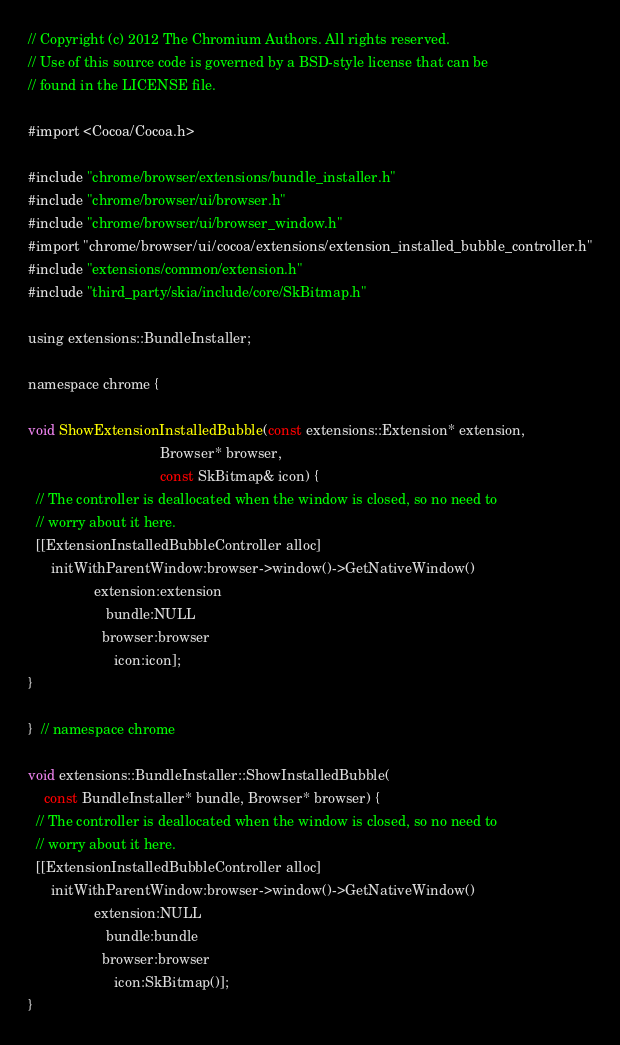Convert code to text. <code><loc_0><loc_0><loc_500><loc_500><_ObjectiveC_>// Copyright (c) 2012 The Chromium Authors. All rights reserved.
// Use of this source code is governed by a BSD-style license that can be
// found in the LICENSE file.

#import <Cocoa/Cocoa.h>

#include "chrome/browser/extensions/bundle_installer.h"
#include "chrome/browser/ui/browser.h"
#include "chrome/browser/ui/browser_window.h"
#import "chrome/browser/ui/cocoa/extensions/extension_installed_bubble_controller.h"
#include "extensions/common/extension.h"
#include "third_party/skia/include/core/SkBitmap.h"

using extensions::BundleInstaller;

namespace chrome {

void ShowExtensionInstalledBubble(const extensions::Extension* extension,
                                  Browser* browser,
                                  const SkBitmap& icon) {
  // The controller is deallocated when the window is closed, so no need to
  // worry about it here.
  [[ExtensionInstalledBubbleController alloc]
      initWithParentWindow:browser->window()->GetNativeWindow()
                 extension:extension
                    bundle:NULL
                   browser:browser
                      icon:icon];
}

}  // namespace chrome

void extensions::BundleInstaller::ShowInstalledBubble(
    const BundleInstaller* bundle, Browser* browser) {
  // The controller is deallocated when the window is closed, so no need to
  // worry about it here.
  [[ExtensionInstalledBubbleController alloc]
      initWithParentWindow:browser->window()->GetNativeWindow()
                 extension:NULL
                    bundle:bundle
                   browser:browser
                      icon:SkBitmap()];
}
</code> 